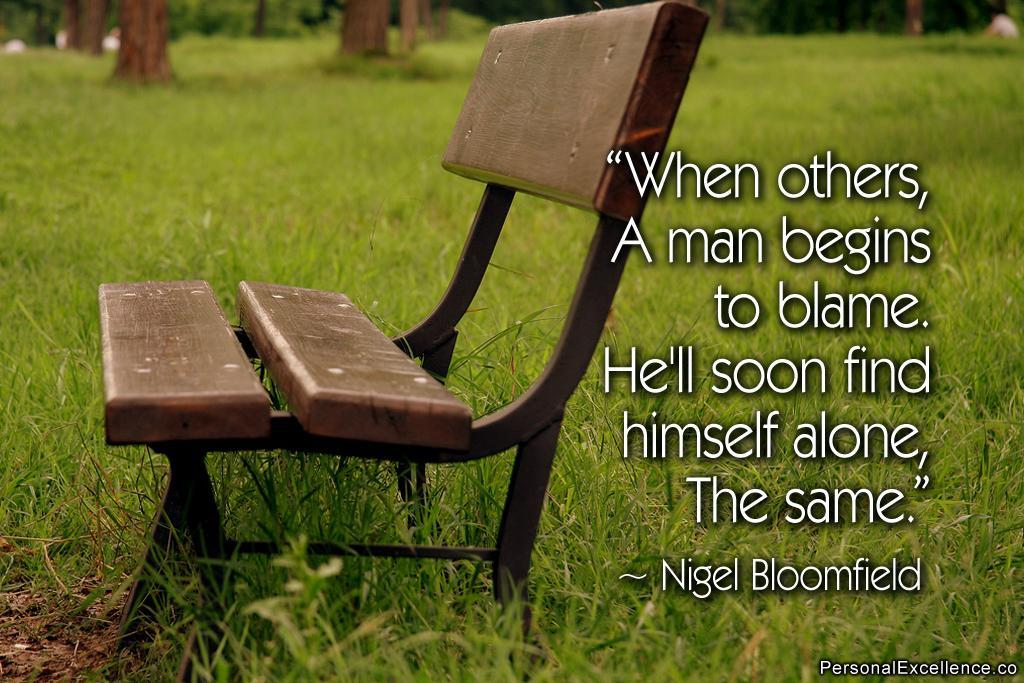What type of vegetation can be seen in the image? There is grass in the image. What else can be seen in the image besides the grass? There are trunks of trees and a bench in the image. Is there anyone in the image? Yes, there is a person in the image. What is written on the right side of the image? There is text written on the right side of the image. What type of stone is the person using to smile in the image? There is no stone present in the image, and the person is not using any object to smile. 